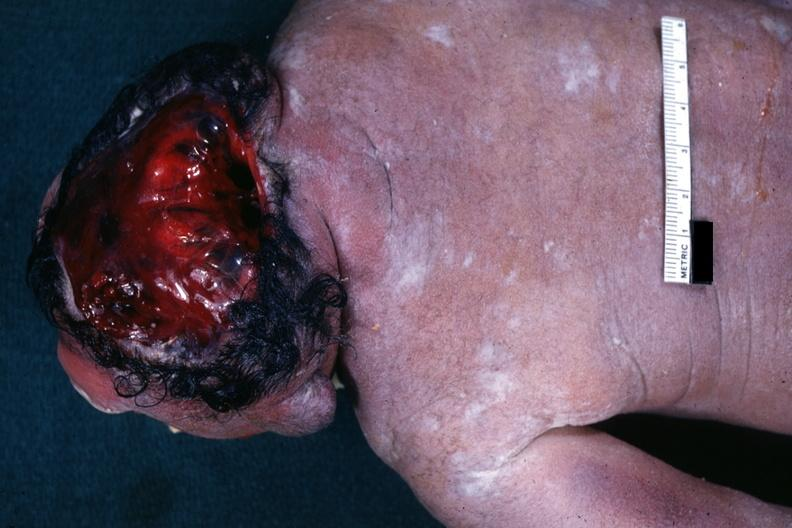what is present?
Answer the question using a single word or phrase. Anencephaly 